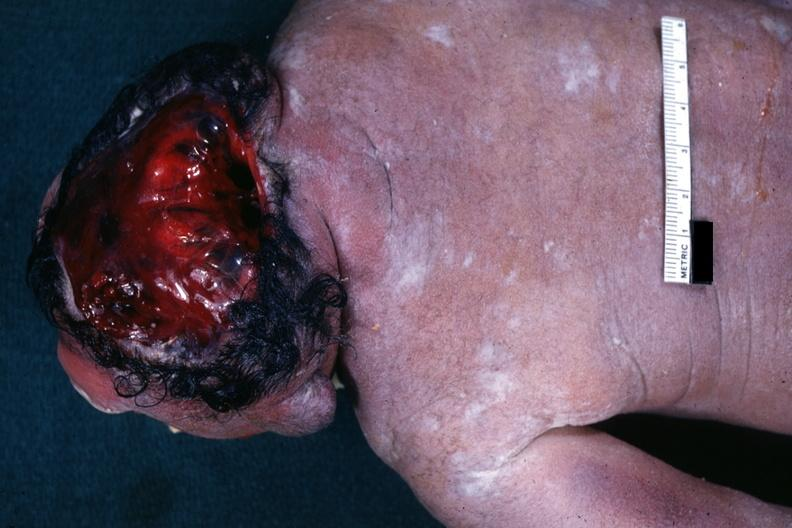what is present?
Answer the question using a single word or phrase. Anencephaly 